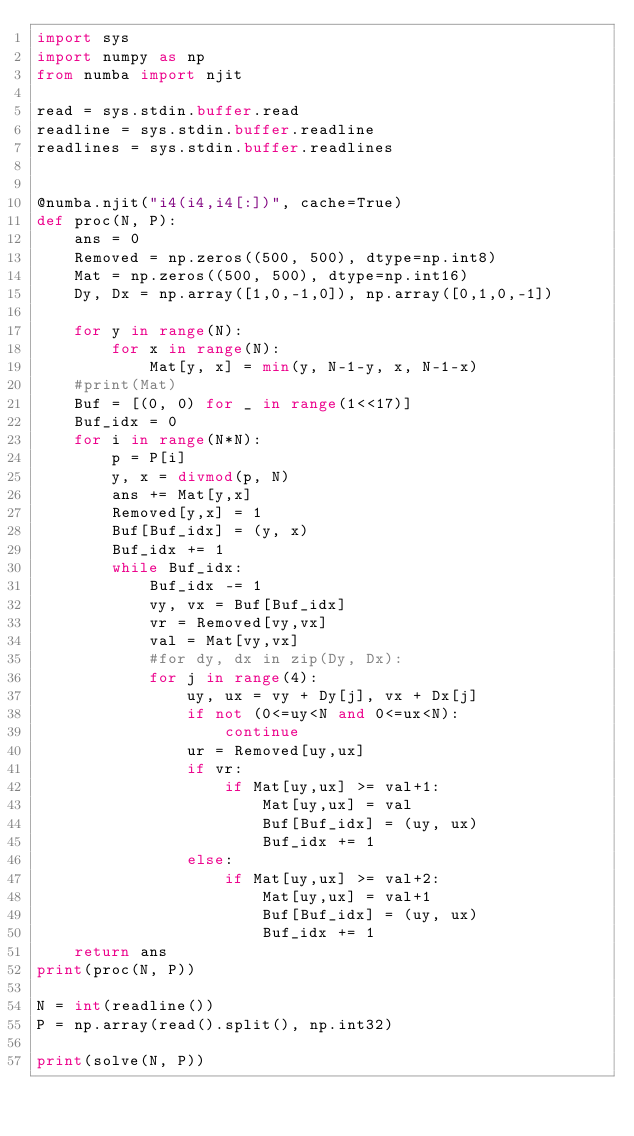<code> <loc_0><loc_0><loc_500><loc_500><_Python_>import sys
import numpy as np
from numba import njit
 
read = sys.stdin.buffer.read
readline = sys.stdin.buffer.readline
readlines = sys.stdin.buffer.readlines


@numba.njit("i4(i4,i4[:])", cache=True)
def proc(N, P):
    ans = 0
    Removed = np.zeros((500, 500), dtype=np.int8)
    Mat = np.zeros((500, 500), dtype=np.int16)
    Dy, Dx = np.array([1,0,-1,0]), np.array([0,1,0,-1])

    for y in range(N):
        for x in range(N):
            Mat[y, x] = min(y, N-1-y, x, N-1-x)
    #print(Mat)
    Buf = [(0, 0) for _ in range(1<<17)]
    Buf_idx = 0
    for i in range(N*N):
        p = P[i]
        y, x = divmod(p, N)
        ans += Mat[y,x]
        Removed[y,x] = 1
        Buf[Buf_idx] = (y, x)
        Buf_idx += 1
        while Buf_idx:
            Buf_idx -= 1
            vy, vx = Buf[Buf_idx]
            vr = Removed[vy,vx]
            val = Mat[vy,vx]
            #for dy, dx in zip(Dy, Dx):
            for j in range(4):
                uy, ux = vy + Dy[j], vx + Dx[j]
                if not (0<=uy<N and 0<=ux<N):
                    continue
                ur = Removed[uy,ux]
                if vr:
                    if Mat[uy,ux] >= val+1:
                        Mat[uy,ux] = val
                        Buf[Buf_idx] = (uy, ux)
                        Buf_idx += 1
                else:
                    if Mat[uy,ux] >= val+2:
                        Mat[uy,ux] = val+1
                        Buf[Buf_idx] = (uy, ux)
                        Buf_idx += 1
    return ans
print(proc(N, P))

N = int(readline())
P = np.array(read().split(), np.int32)
 
print(solve(N, P))</code> 